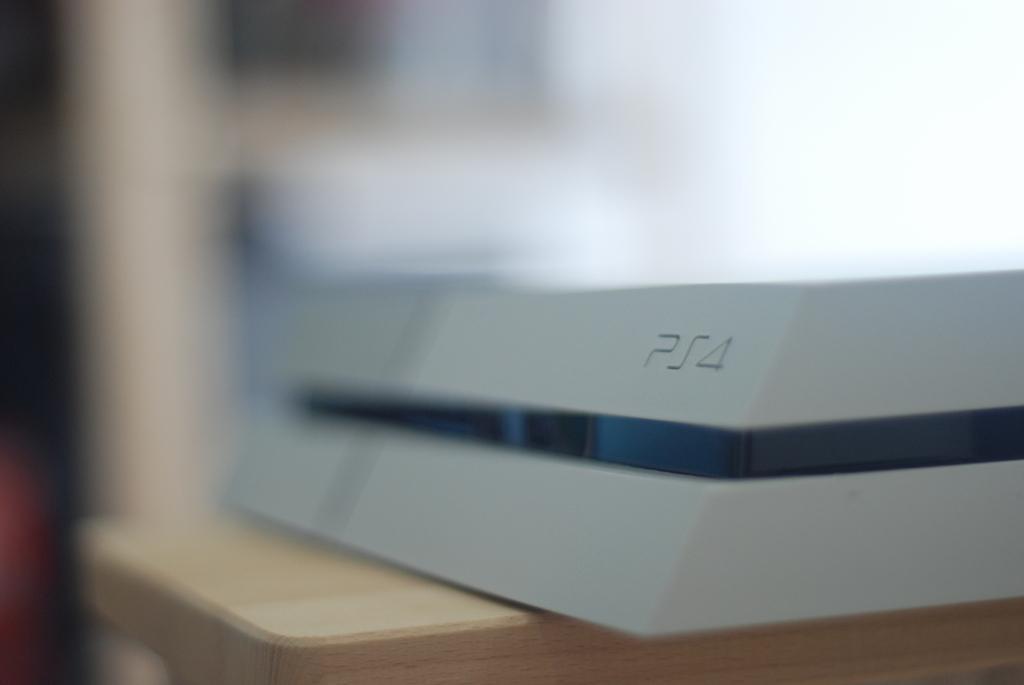How would you summarize this image in a sentence or two? In the picture we can see a wooden plank on it we can see some material which is white in color and in the middle we can see a black color line on it. 